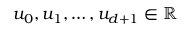Convert formula to latex. <formula><loc_0><loc_0><loc_500><loc_500>u _ { 0 } , u _ { 1 } , \dots , u _ { d + 1 } \in \mathbb { R }</formula> 